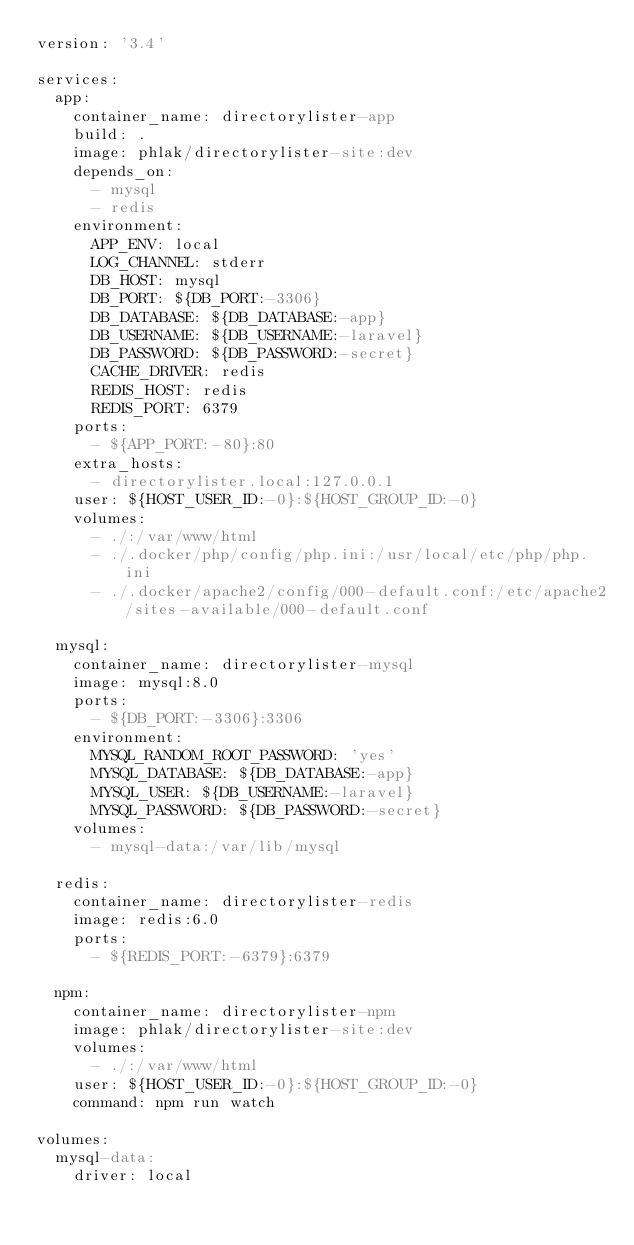<code> <loc_0><loc_0><loc_500><loc_500><_YAML_>version: '3.4'

services:
  app:
    container_name: directorylister-app
    build: .
    image: phlak/directorylister-site:dev
    depends_on:
      - mysql
      - redis
    environment:
      APP_ENV: local
      LOG_CHANNEL: stderr
      DB_HOST: mysql
      DB_PORT: ${DB_PORT:-3306}
      DB_DATABASE: ${DB_DATABASE:-app}
      DB_USERNAME: ${DB_USERNAME:-laravel}
      DB_PASSWORD: ${DB_PASSWORD:-secret}
      CACHE_DRIVER: redis
      REDIS_HOST: redis
      REDIS_PORT: 6379
    ports:
      - ${APP_PORT:-80}:80
    extra_hosts:
      - directorylister.local:127.0.0.1
    user: ${HOST_USER_ID:-0}:${HOST_GROUP_ID:-0}
    volumes:
      - ./:/var/www/html
      - ./.docker/php/config/php.ini:/usr/local/etc/php/php.ini
      - ./.docker/apache2/config/000-default.conf:/etc/apache2/sites-available/000-default.conf

  mysql:
    container_name: directorylister-mysql
    image: mysql:8.0
    ports:
      - ${DB_PORT:-3306}:3306
    environment:
      MYSQL_RANDOM_ROOT_PASSWORD: 'yes'
      MYSQL_DATABASE: ${DB_DATABASE:-app}
      MYSQL_USER: ${DB_USERNAME:-laravel}
      MYSQL_PASSWORD: ${DB_PASSWORD:-secret}
    volumes:
      - mysql-data:/var/lib/mysql

  redis:
    container_name: directorylister-redis
    image: redis:6.0
    ports:
      - ${REDIS_PORT:-6379}:6379

  npm:
    container_name: directorylister-npm
    image: phlak/directorylister-site:dev
    volumes:
      - ./:/var/www/html
    user: ${HOST_USER_ID:-0}:${HOST_GROUP_ID:-0}
    command: npm run watch

volumes:
  mysql-data:
    driver: local
</code> 